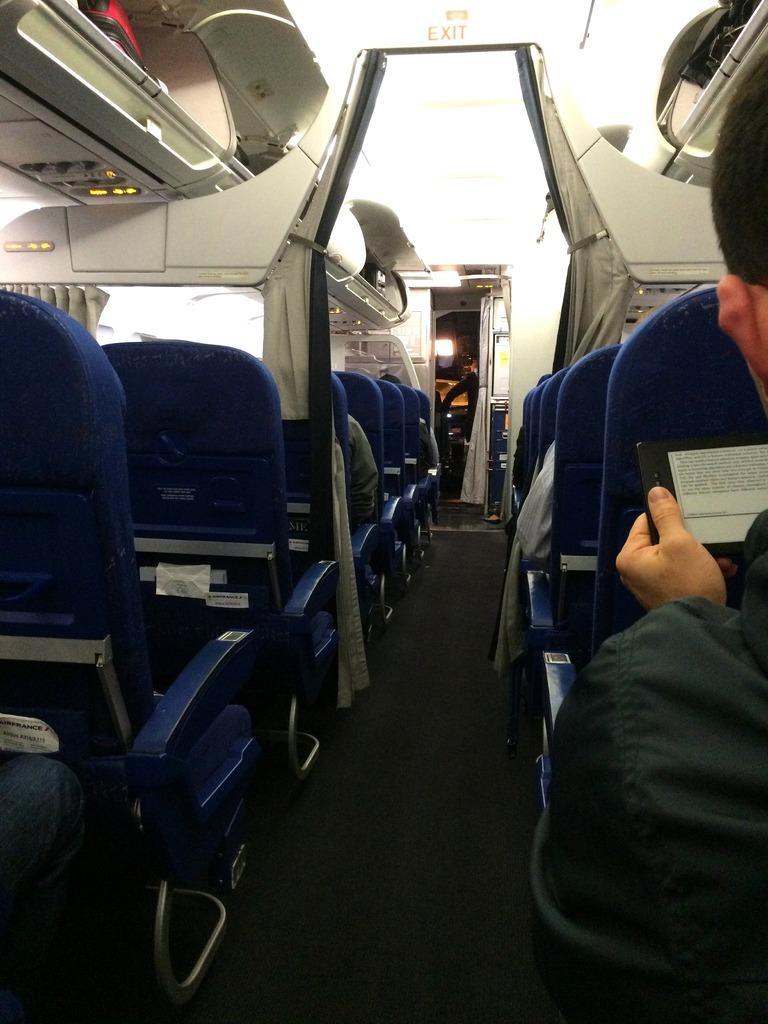What type of location is depicted in the image? The image is an inside view of an airplane. What can be found inside the airplane? There are seats, lights, curtains, and two persons in the airplane. What type of square object can be seen in the story of the image? There is no square object or story present in the image; it is a photograph of an airplane's interior. 